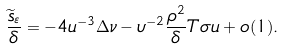<formula> <loc_0><loc_0><loc_500><loc_500>\frac { \widetilde { s } _ { \varepsilon } } { \delta } = - 4 u ^ { - 3 } \Delta \nu - \upsilon ^ { - 2 } \frac { \rho ^ { 2 } } { \delta } T \sigma u + o ( 1 ) .</formula> 